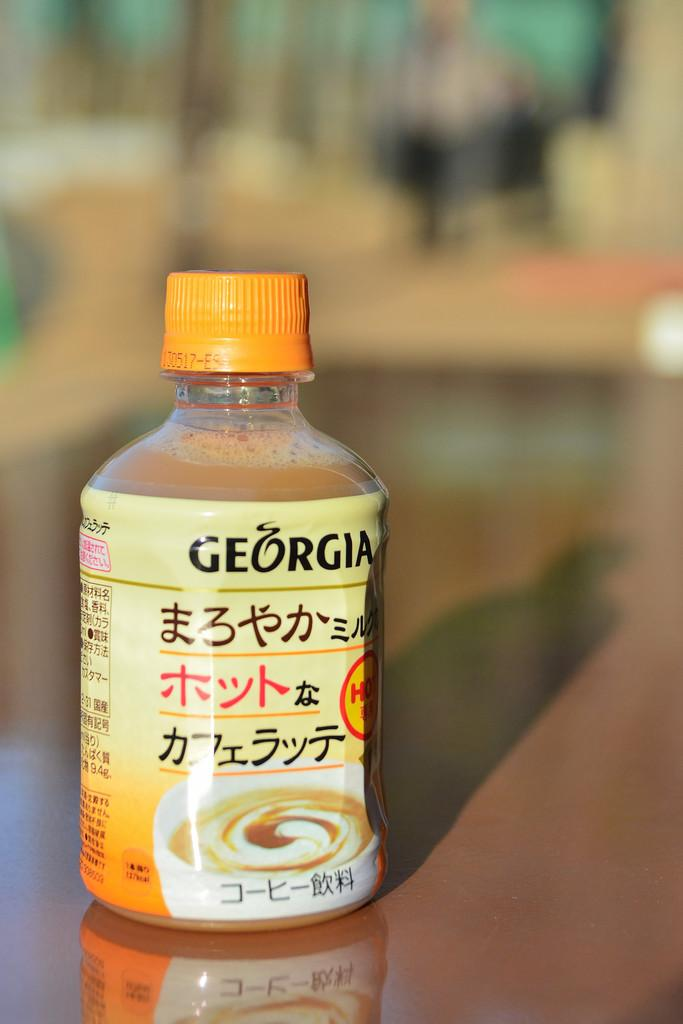<image>
Offer a succinct explanation of the picture presented. a liquid drink with chinese writing from Georgia 